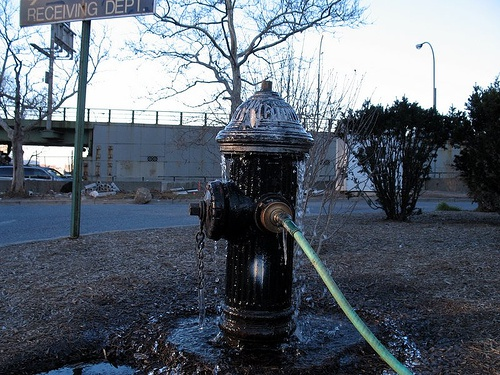Describe the objects in this image and their specific colors. I can see fire hydrant in white, black, gray, and navy tones and car in white, black, navy, darkblue, and gray tones in this image. 